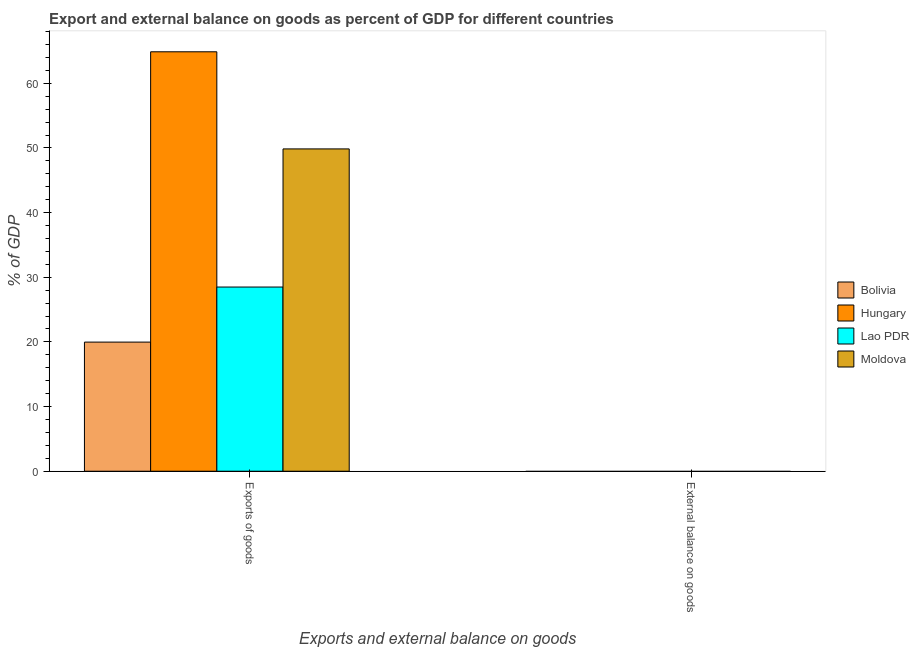How many different coloured bars are there?
Your answer should be compact. 4. Are the number of bars on each tick of the X-axis equal?
Make the answer very short. No. How many bars are there on the 2nd tick from the left?
Ensure brevity in your answer.  0. How many bars are there on the 2nd tick from the right?
Give a very brief answer. 4. What is the label of the 1st group of bars from the left?
Provide a short and direct response. Exports of goods. Across all countries, what is the maximum export of goods as percentage of gdp?
Provide a short and direct response. 64.87. Across all countries, what is the minimum external balance on goods as percentage of gdp?
Provide a succinct answer. 0. In which country was the export of goods as percentage of gdp maximum?
Your answer should be very brief. Hungary. What is the total external balance on goods as percentage of gdp in the graph?
Provide a short and direct response. 0. What is the difference between the export of goods as percentage of gdp in Bolivia and that in Lao PDR?
Keep it short and to the point. -8.52. What is the difference between the export of goods as percentage of gdp in Hungary and the external balance on goods as percentage of gdp in Bolivia?
Offer a very short reply. 64.87. What is the average external balance on goods as percentage of gdp per country?
Make the answer very short. 0. What is the ratio of the export of goods as percentage of gdp in Moldova to that in Bolivia?
Your response must be concise. 2.5. Is the export of goods as percentage of gdp in Lao PDR less than that in Moldova?
Make the answer very short. Yes. In how many countries, is the export of goods as percentage of gdp greater than the average export of goods as percentage of gdp taken over all countries?
Your answer should be compact. 2. How many bars are there?
Keep it short and to the point. 4. How many countries are there in the graph?
Keep it short and to the point. 4. Where does the legend appear in the graph?
Give a very brief answer. Center right. How many legend labels are there?
Your answer should be very brief. 4. What is the title of the graph?
Your response must be concise. Export and external balance on goods as percent of GDP for different countries. What is the label or title of the X-axis?
Provide a short and direct response. Exports and external balance on goods. What is the label or title of the Y-axis?
Your response must be concise. % of GDP. What is the % of GDP in Bolivia in Exports of goods?
Your answer should be very brief. 19.97. What is the % of GDP in Hungary in Exports of goods?
Provide a short and direct response. 64.87. What is the % of GDP of Lao PDR in Exports of goods?
Give a very brief answer. 28.49. What is the % of GDP in Moldova in Exports of goods?
Give a very brief answer. 49.85. What is the % of GDP in Bolivia in External balance on goods?
Your answer should be compact. 0. Across all Exports and external balance on goods, what is the maximum % of GDP of Bolivia?
Offer a very short reply. 19.97. Across all Exports and external balance on goods, what is the maximum % of GDP in Hungary?
Give a very brief answer. 64.87. Across all Exports and external balance on goods, what is the maximum % of GDP of Lao PDR?
Your answer should be very brief. 28.49. Across all Exports and external balance on goods, what is the maximum % of GDP in Moldova?
Give a very brief answer. 49.85. What is the total % of GDP of Bolivia in the graph?
Your answer should be compact. 19.97. What is the total % of GDP of Hungary in the graph?
Your answer should be very brief. 64.87. What is the total % of GDP in Lao PDR in the graph?
Provide a short and direct response. 28.49. What is the total % of GDP of Moldova in the graph?
Your response must be concise. 49.85. What is the average % of GDP in Bolivia per Exports and external balance on goods?
Your answer should be compact. 9.99. What is the average % of GDP in Hungary per Exports and external balance on goods?
Ensure brevity in your answer.  32.44. What is the average % of GDP of Lao PDR per Exports and external balance on goods?
Offer a terse response. 14.24. What is the average % of GDP in Moldova per Exports and external balance on goods?
Make the answer very short. 24.93. What is the difference between the % of GDP of Bolivia and % of GDP of Hungary in Exports of goods?
Give a very brief answer. -44.9. What is the difference between the % of GDP of Bolivia and % of GDP of Lao PDR in Exports of goods?
Provide a succinct answer. -8.52. What is the difference between the % of GDP in Bolivia and % of GDP in Moldova in Exports of goods?
Offer a terse response. -29.88. What is the difference between the % of GDP of Hungary and % of GDP of Lao PDR in Exports of goods?
Keep it short and to the point. 36.39. What is the difference between the % of GDP of Hungary and % of GDP of Moldova in Exports of goods?
Your answer should be very brief. 15.02. What is the difference between the % of GDP in Lao PDR and % of GDP in Moldova in Exports of goods?
Your answer should be compact. -21.37. What is the difference between the highest and the lowest % of GDP of Bolivia?
Make the answer very short. 19.97. What is the difference between the highest and the lowest % of GDP of Hungary?
Provide a short and direct response. 64.87. What is the difference between the highest and the lowest % of GDP in Lao PDR?
Ensure brevity in your answer.  28.49. What is the difference between the highest and the lowest % of GDP of Moldova?
Give a very brief answer. 49.85. 